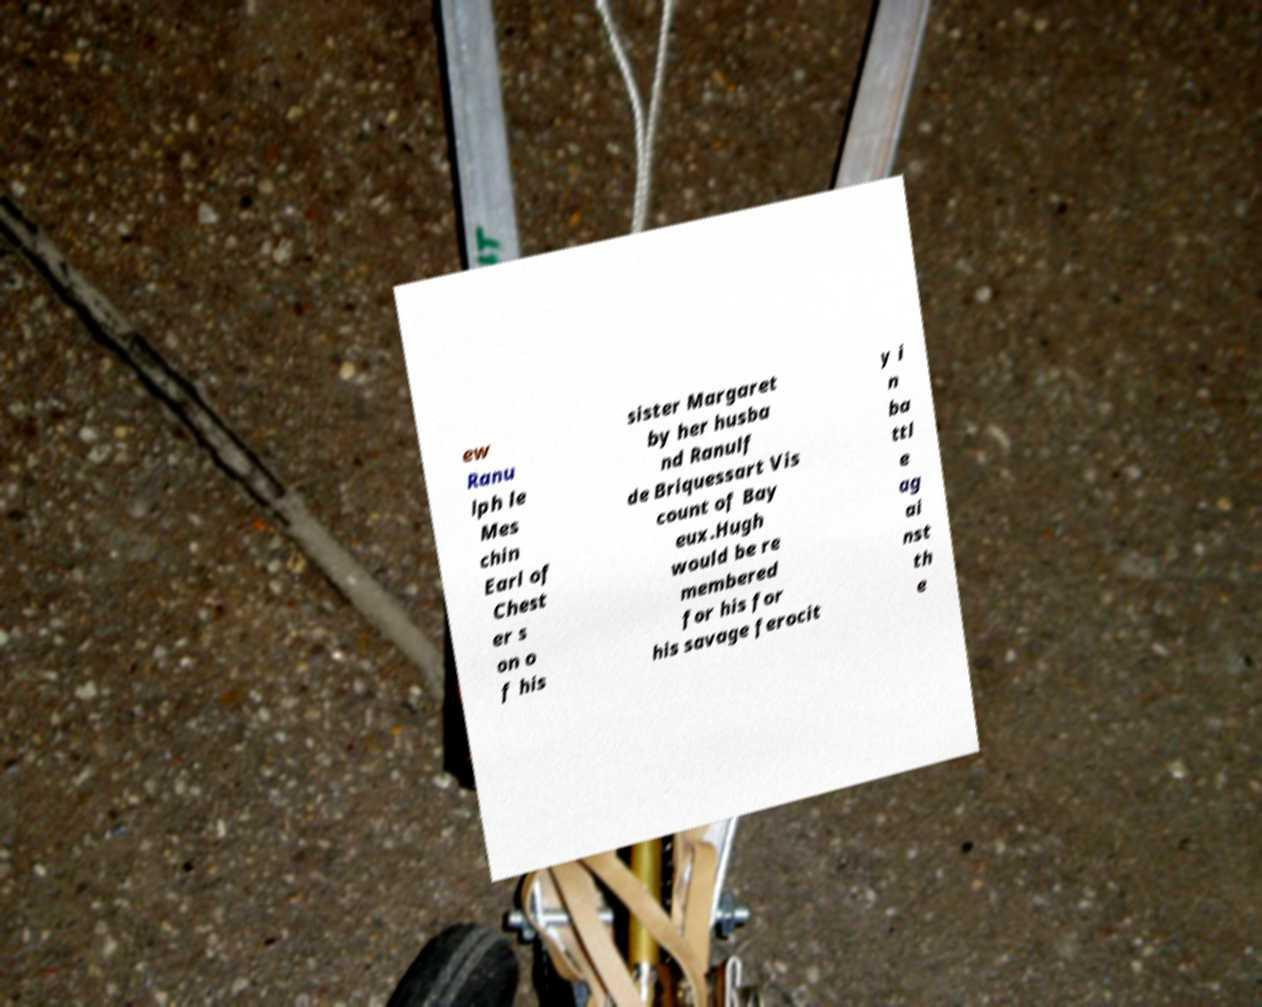For documentation purposes, I need the text within this image transcribed. Could you provide that? ew Ranu lph le Mes chin Earl of Chest er s on o f his sister Margaret by her husba nd Ranulf de Briquessart Vis count of Bay eux.Hugh would be re membered for his for his savage ferocit y i n ba ttl e ag ai nst th e 